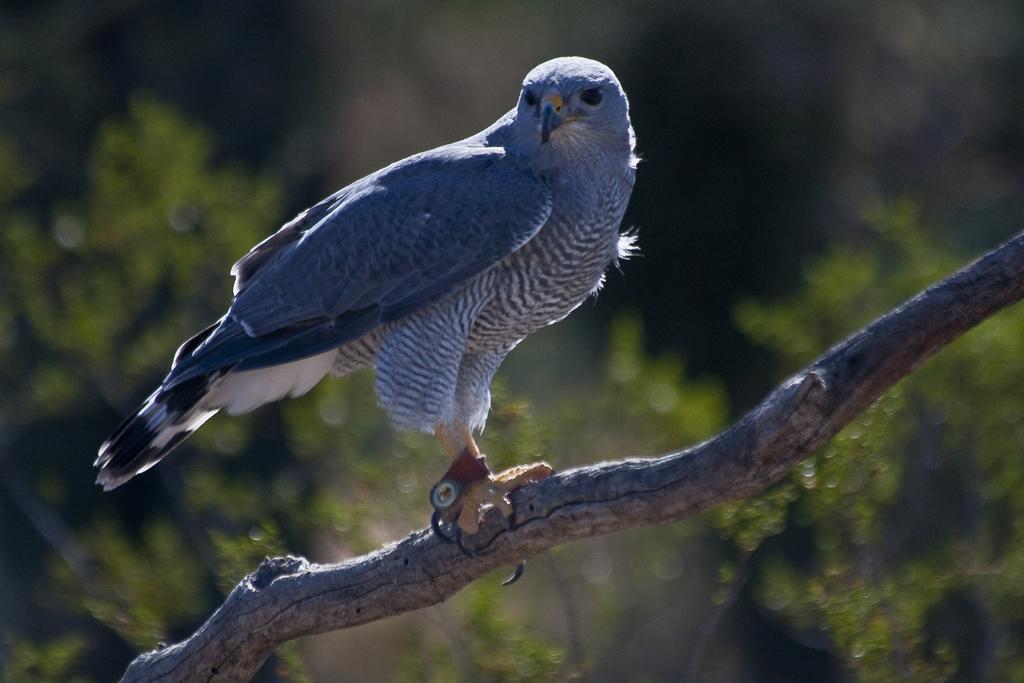In one or two sentences, can you explain what this image depicts? Here we can see a bird on the branch. There is a blur background with greenery. 